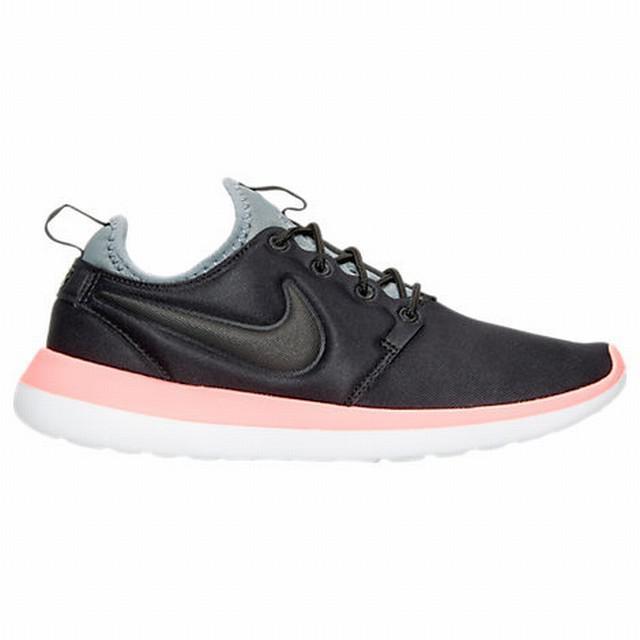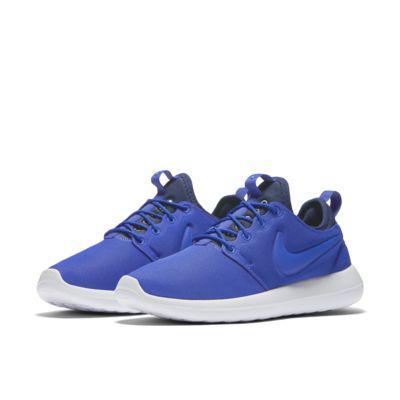The first image is the image on the left, the second image is the image on the right. For the images shown, is this caption "There are two shoes, both pointing in the same direction" true? Answer yes or no. No. The first image is the image on the left, the second image is the image on the right. Evaluate the accuracy of this statement regarding the images: "One of the shoes has a coral pink and white sole.". Is it true? Answer yes or no. Yes. 